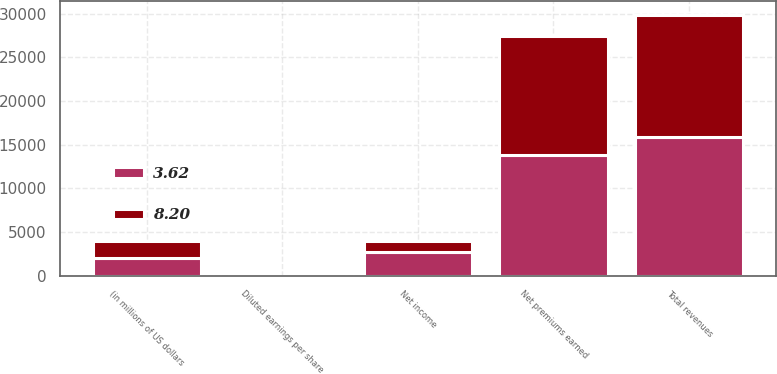Convert chart to OTSL. <chart><loc_0><loc_0><loc_500><loc_500><stacked_bar_chart><ecel><fcel>(in millions of US dollars<fcel>Net premiums earned<fcel>Total revenues<fcel>Net income<fcel>Diluted earnings per share<nl><fcel>8.2<fcel>2008<fcel>13596<fcel>14064<fcel>1234<fcel>3.62<nl><fcel>3.62<fcel>2007<fcel>13823<fcel>15830<fcel>2767<fcel>8.2<nl></chart> 